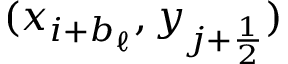<formula> <loc_0><loc_0><loc_500><loc_500>( x _ { i + b _ { \ell } } , y _ { j + \frac { 1 } { 2 } } )</formula> 